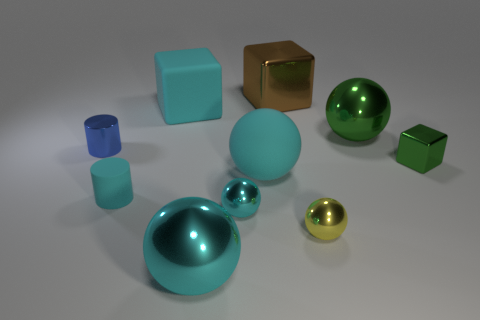The cylinder that is made of the same material as the small cube is what size?
Ensure brevity in your answer.  Small. There is a large shiny sphere that is in front of the yellow metallic ball that is in front of the brown shiny block; what number of tiny shiny cylinders are right of it?
Your answer should be compact. 0. There is a rubber cube; is its color the same as the cylinder that is in front of the tiny metallic cylinder?
Offer a terse response. Yes. There is a small shiny object that is the same color as the matte ball; what shape is it?
Offer a terse response. Sphere. There is a cube on the left side of the cyan object that is in front of the cyan shiny object on the right side of the large cyan metallic ball; what is it made of?
Offer a very short reply. Rubber. Is the shape of the cyan rubber thing that is behind the tiny green metallic block the same as  the small yellow metallic object?
Provide a succinct answer. No. What material is the small block behind the yellow ball?
Offer a terse response. Metal. How many rubber things are either blocks or big balls?
Ensure brevity in your answer.  2. Are there any brown shiny objects that have the same size as the yellow sphere?
Give a very brief answer. No. Is the number of small green shiny cubes that are behind the large green object greater than the number of tiny blue objects?
Offer a terse response. No. 